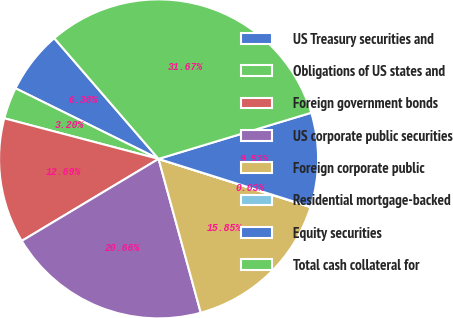<chart> <loc_0><loc_0><loc_500><loc_500><pie_chart><fcel>US Treasury securities and<fcel>Obligations of US states and<fcel>Foreign government bonds<fcel>US corporate public securities<fcel>Foreign corporate public<fcel>Residential mortgage-backed<fcel>Equity securities<fcel>Total cash collateral for<nl><fcel>6.36%<fcel>3.2%<fcel>12.69%<fcel>20.66%<fcel>15.85%<fcel>0.03%<fcel>9.53%<fcel>31.67%<nl></chart> 